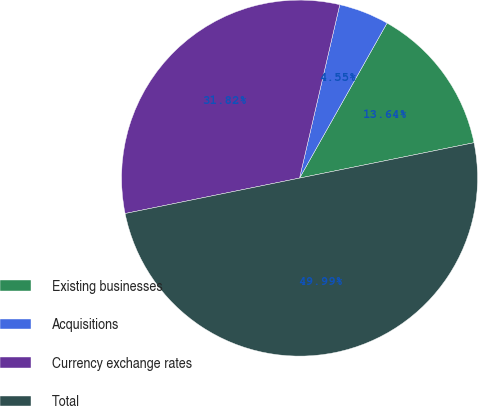Convert chart. <chart><loc_0><loc_0><loc_500><loc_500><pie_chart><fcel>Existing businesses<fcel>Acquisitions<fcel>Currency exchange rates<fcel>Total<nl><fcel>13.64%<fcel>4.55%<fcel>31.82%<fcel>50.0%<nl></chart> 